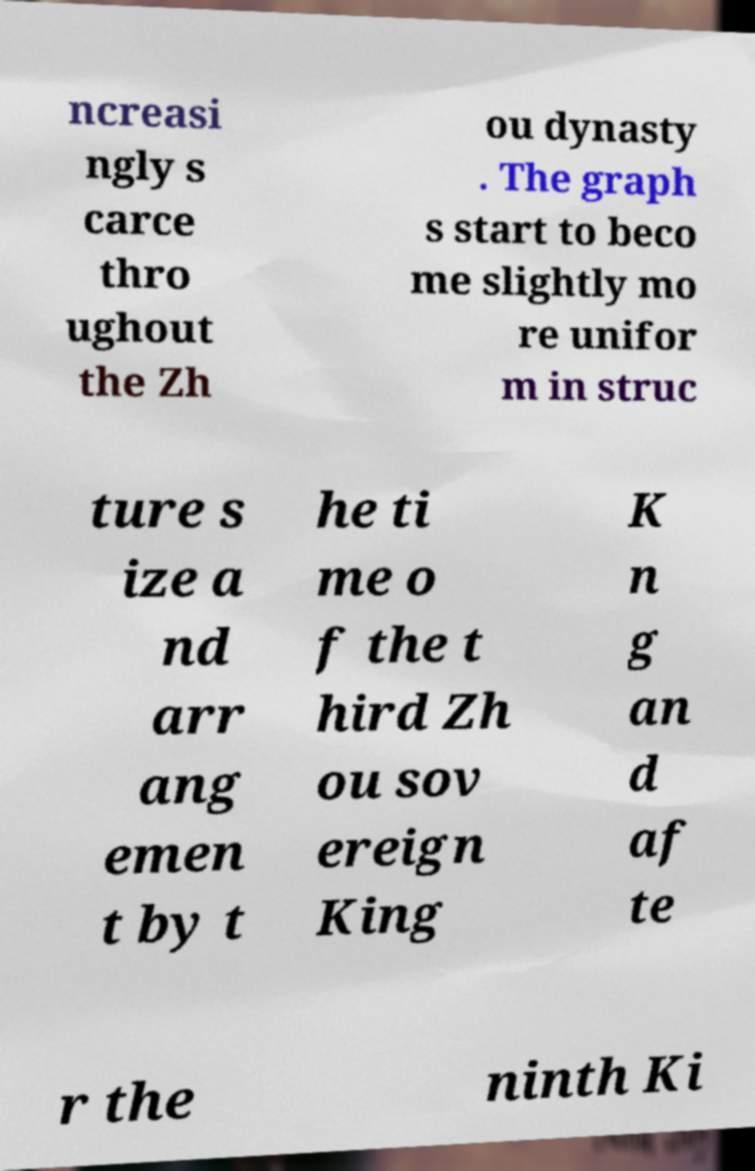Could you extract and type out the text from this image? ncreasi ngly s carce thro ughout the Zh ou dynasty . The graph s start to beco me slightly mo re unifor m in struc ture s ize a nd arr ang emen t by t he ti me o f the t hird Zh ou sov ereign King K n g an d af te r the ninth Ki 